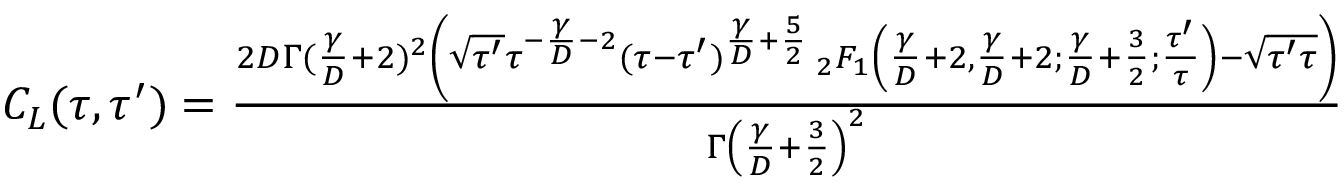Convert formula to latex. <formula><loc_0><loc_0><loc_500><loc_500>\begin{array} { r } { C _ { L } ( \tau , \tau ^ { \prime } ) = \frac { 2 D \Gamma ( \frac { \gamma } { D } + 2 ) ^ { 2 } \left ( \sqrt { \tau ^ { \prime } } \tau ^ { - \frac { \gamma } { D } - 2 } ( \tau - \tau ^ { \prime } ) ^ { \frac { \gamma } { D } + \frac { 5 } { 2 } } \, _ { 2 } F _ { 1 } \left ( \frac { \gamma } { D } + 2 , \frac { \gamma } { D } + 2 ; \frac { \gamma } { D } + \frac { 3 } { 2 } ; \frac { \tau ^ { \prime } } { \tau } \right ) - \sqrt { \tau ^ { \prime } \tau } \right ) } { \Gamma \left ( \frac { \gamma } { D } + \frac { 3 } { 2 } \right ) ^ { 2 } } } \end{array}</formula> 